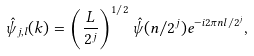<formula> <loc_0><loc_0><loc_500><loc_500>\hat { \psi } _ { j , l } ( k ) = \left ( \frac { L } { 2 ^ { j } } \right ) ^ { 1 / 2 } \hat { \psi } ( n / 2 ^ { j } ) e ^ { - i 2 \pi n l / 2 ^ { j } } ,</formula> 